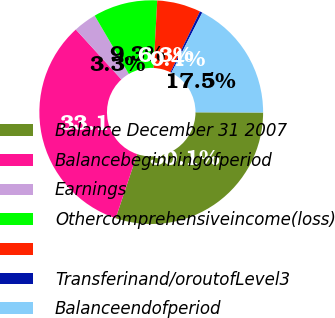Convert chart to OTSL. <chart><loc_0><loc_0><loc_500><loc_500><pie_chart><fcel>Balance December 31 2007<fcel>Balancebeginningofperiod<fcel>Earnings<fcel>Othercomprehensiveincome(loss)<fcel>Unnamed: 4<fcel>Transferinand/oroutofLevel3<fcel>Balanceendofperiod<nl><fcel>30.1%<fcel>33.08%<fcel>3.34%<fcel>9.29%<fcel>6.32%<fcel>0.37%<fcel>17.51%<nl></chart> 